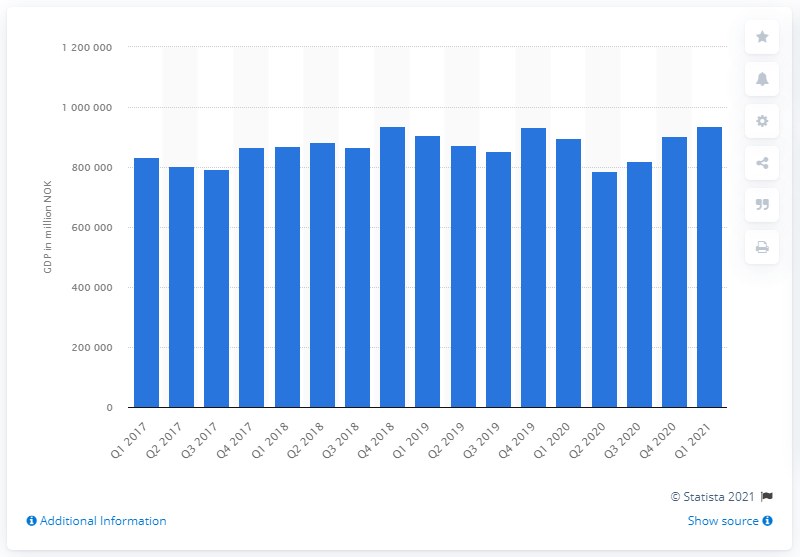Specify some key components in this picture. In the first quarter of 2021, the Gross Domestic Product (GDP) of Norway was 937,345 million U.S. dollars. 